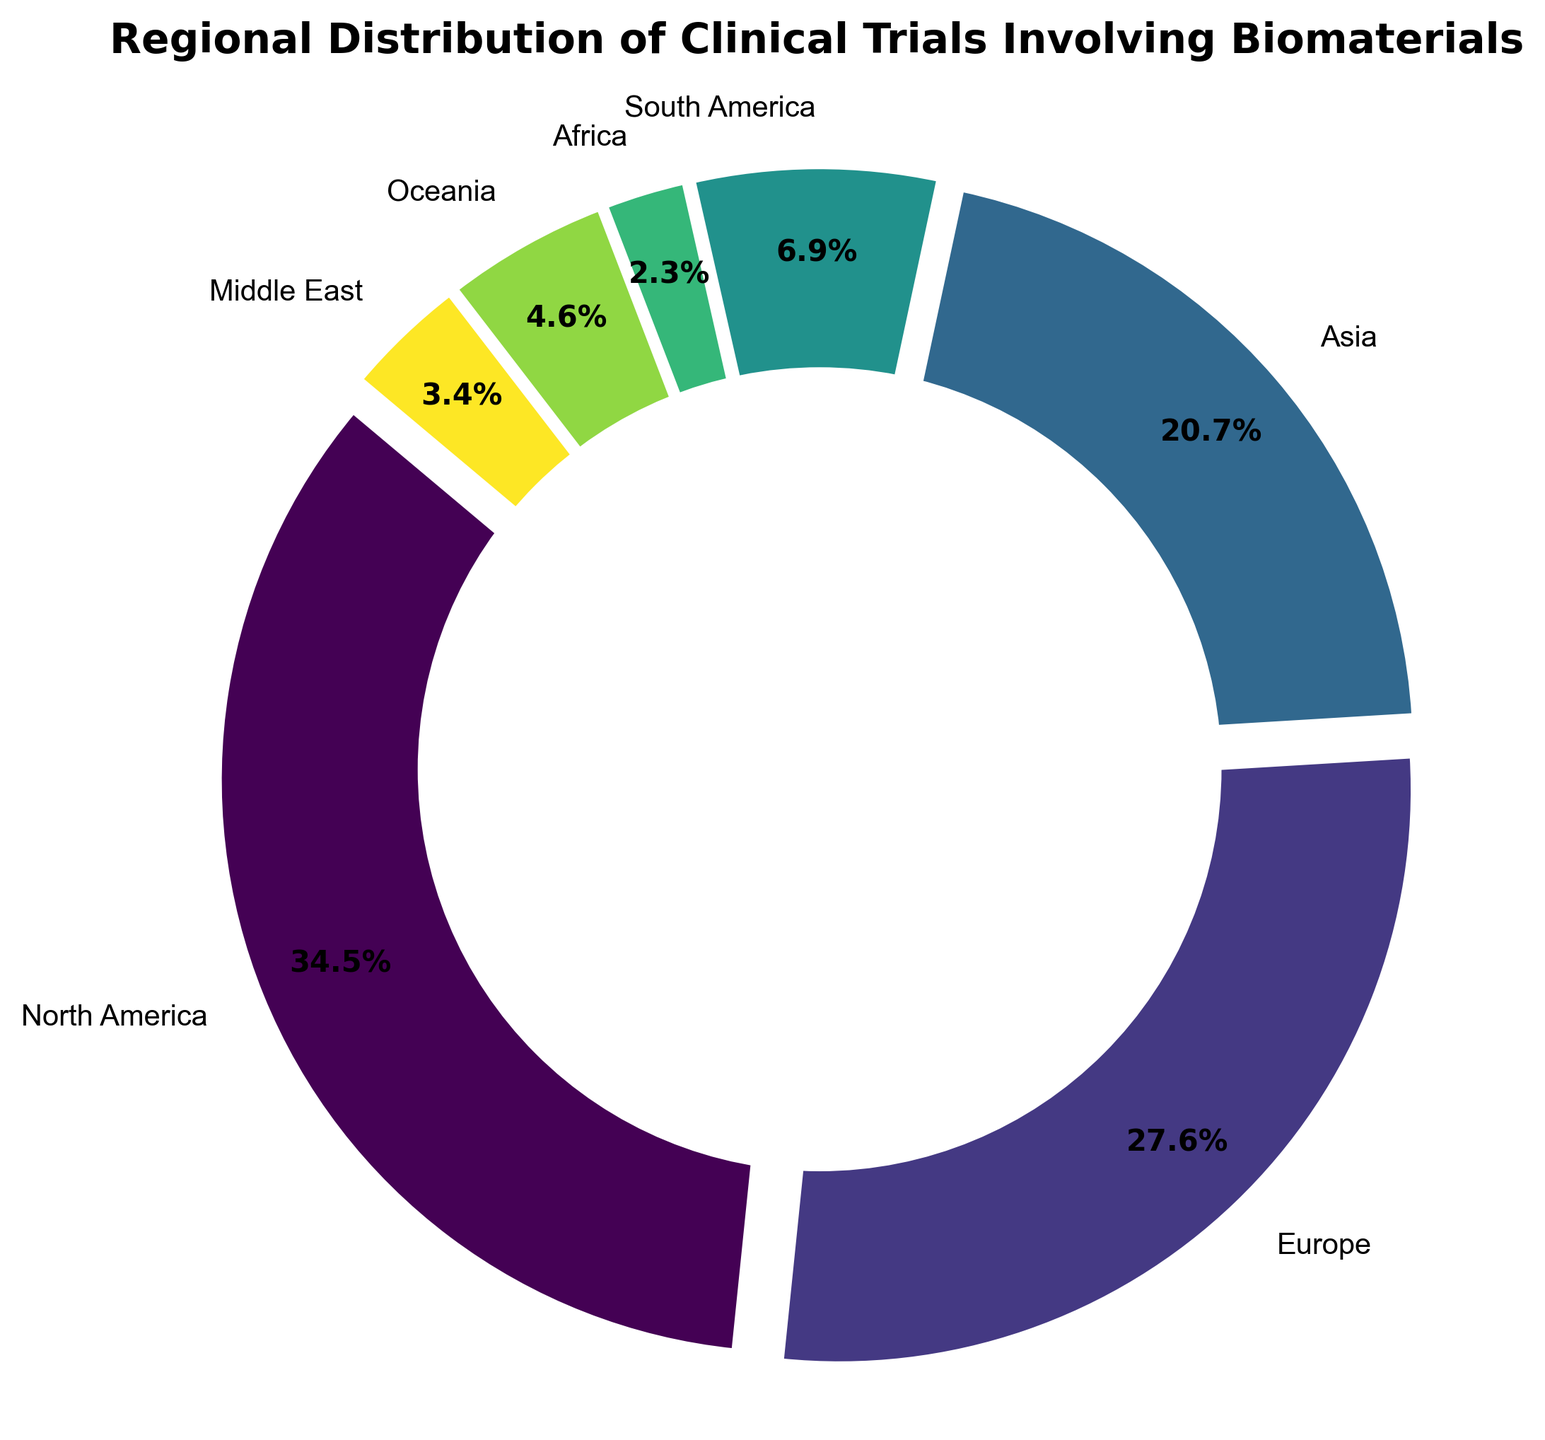What percentage of clinical trials are conducted in North America? To find the percentage of clinical trials conducted in North America, you can simply refer to the figure where North America's segment is clearly labeled with its percentage.
Answer: 40.0% How many regions have clinical trials accounting for less than 10% each? By looking at the pie chart, identify and count the regions where the percentage is less than 10%. Those regions include South America, Africa, Oceania, and the Middle East. Each percentage is shown beside the region's label in the figure.
Answer: 4 What is the total percentage of clinical trials conducted in Europe and Asia combined? Add the percentages of clinical trials in Europe and Asia. These values are indicated next to their corresponding segments in the pie chart. Europe is 32.0%, and Asia is 24.0%. So, 32.0% + 24.0% = 56.0%.
Answer: 56.0% Which two regions have the smallest number of clinical trials, and how many combined trials do they have? From the pie chart, identify the two smallest segments, which represent Africa and the Middle East. The number of clinical trials in Africa is 10, and in the Middle East, it is 15. Add these two numbers together: 10 + 15 = 25.
Answer: Africa and the Middle East, 25 How does the percentage of clinical trials in South America compare to Oceania? Find the segments for South America and Oceania and compare their percentages. South America is 8.0%, and Oceania is 12.0%.
Answer: South America has a smaller percentage than Oceania What is the difference in the number of clinical trials between Asia and South America? Subtract the number of clinical trials in South America from those in Asia. Asia has 90 trials, and South America has 30 trials. So, 90 - 30 = 60.
Answer: 60 What is the average number of clinical trials conducted in Oceania, the Middle East, and Africa? Add the number of clinical trials in Oceania (20), the Middle East (15), and Africa (10) and divide by the number of regions (3). (20 + 15 + 10) / 3 = 45 / 3 = 15.
Answer: 15 Which region has the third largest number of clinical trials, and what is the number? By looking at the size of segments, identify that Asia has the third largest share after North America and Europe. Asia has 90 clinical trials.
Answer: Asia, 90 